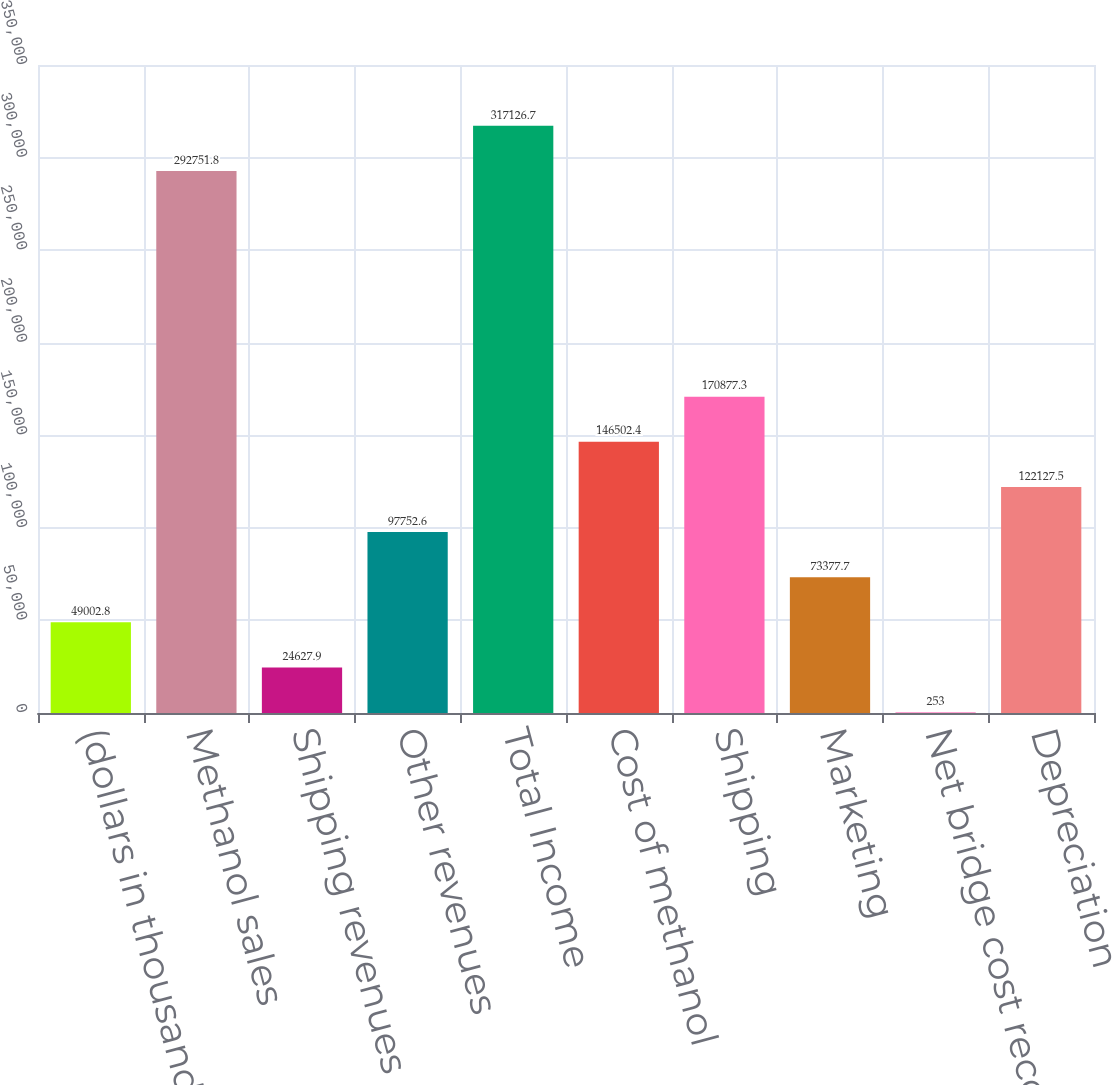Convert chart to OTSL. <chart><loc_0><loc_0><loc_500><loc_500><bar_chart><fcel>(dollars in thousands)<fcel>Methanol sales<fcel>Shipping revenues<fcel>Other revenues<fcel>Total Income<fcel>Cost of methanol<fcel>Shipping<fcel>Marketing<fcel>Net bridge cost recovery loss<fcel>Depreciation<nl><fcel>49002.8<fcel>292752<fcel>24627.9<fcel>97752.6<fcel>317127<fcel>146502<fcel>170877<fcel>73377.7<fcel>253<fcel>122128<nl></chart> 